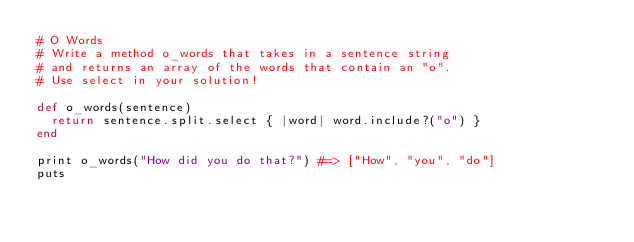<code> <loc_0><loc_0><loc_500><loc_500><_Ruby_># O Words
# Write a method o_words that takes in a sentence string
# and returns an array of the words that contain an "o".
# Use select in your solution!

def o_words(sentence)
  return sentence.split.select { |word| word.include?("o") }
end

print o_words("How did you do that?") #=> ["How", "you", "do"]
puts</code> 